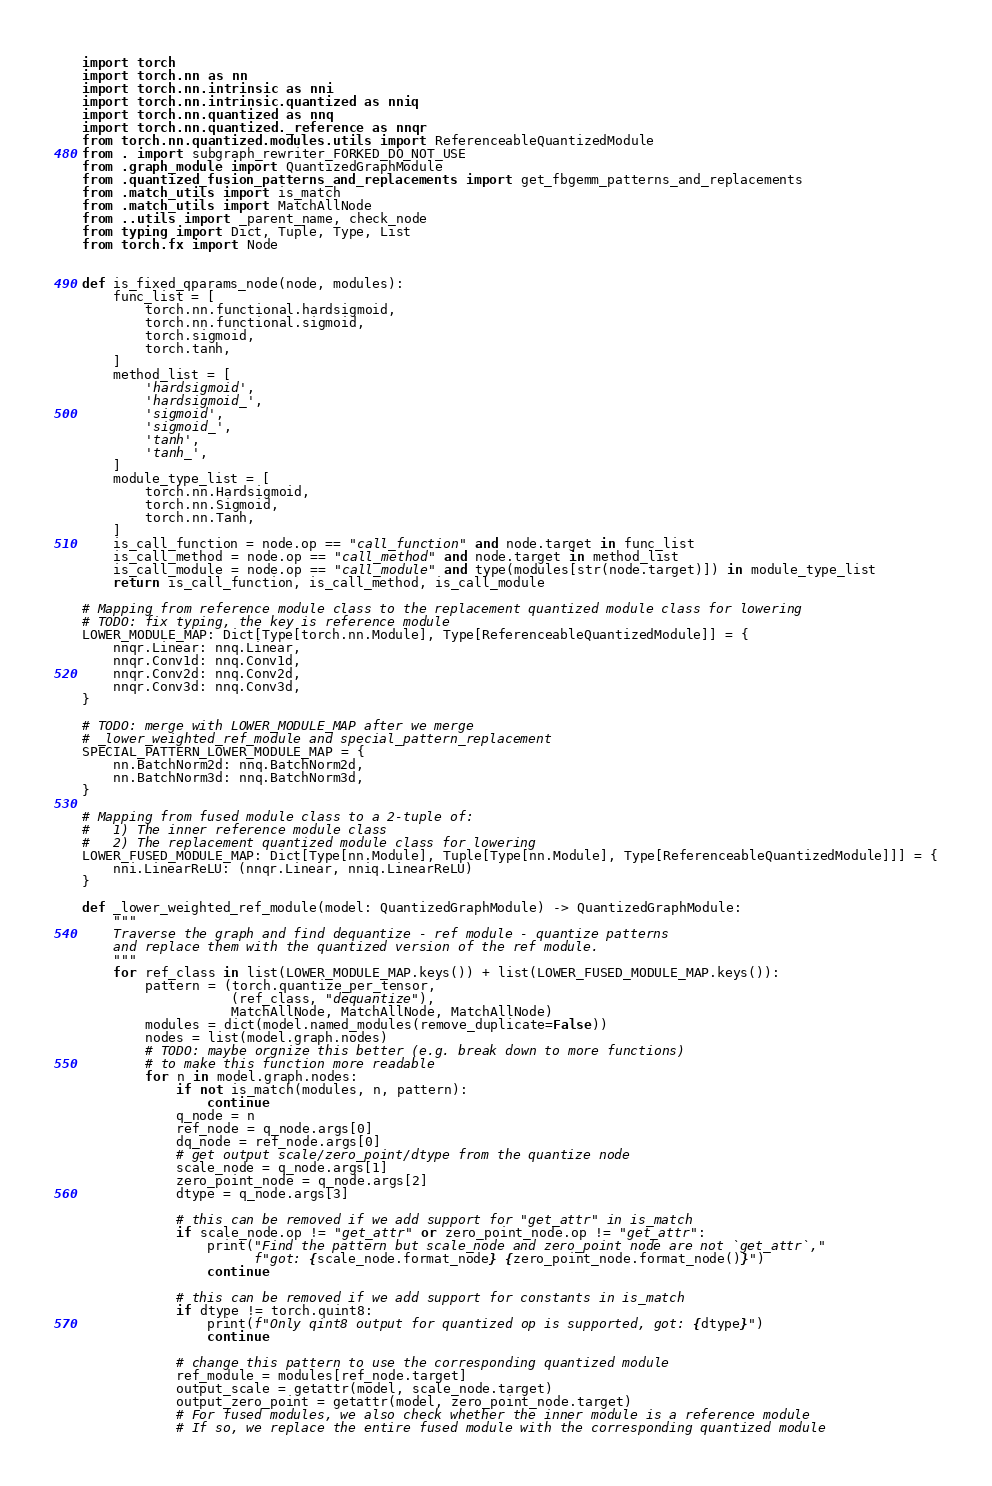Convert code to text. <code><loc_0><loc_0><loc_500><loc_500><_Python_>import torch
import torch.nn as nn
import torch.nn.intrinsic as nni
import torch.nn.intrinsic.quantized as nniq
import torch.nn.quantized as nnq
import torch.nn.quantized._reference as nnqr
from torch.nn.quantized.modules.utils import ReferenceableQuantizedModule
from . import subgraph_rewriter_FORKED_DO_NOT_USE
from .graph_module import QuantizedGraphModule
from .quantized_fusion_patterns_and_replacements import get_fbgemm_patterns_and_replacements
from .match_utils import is_match
from .match_utils import MatchAllNode
from ..utils import _parent_name, check_node
from typing import Dict, Tuple, Type, List
from torch.fx import Node


def is_fixed_qparams_node(node, modules):
    func_list = [
        torch.nn.functional.hardsigmoid,
        torch.nn.functional.sigmoid,
        torch.sigmoid,
        torch.tanh,
    ]
    method_list = [
        'hardsigmoid',
        'hardsigmoid_',
        'sigmoid',
        'sigmoid_',
        'tanh',
        'tanh_',
    ]
    module_type_list = [
        torch.nn.Hardsigmoid,
        torch.nn.Sigmoid,
        torch.nn.Tanh,
    ]
    is_call_function = node.op == "call_function" and node.target in func_list
    is_call_method = node.op == "call_method" and node.target in method_list
    is_call_module = node.op == "call_module" and type(modules[str(node.target)]) in module_type_list
    return is_call_function, is_call_method, is_call_module

# Mapping from reference module class to the replacement quantized module class for lowering
# TODO: fix typing, the key is reference module
LOWER_MODULE_MAP: Dict[Type[torch.nn.Module], Type[ReferenceableQuantizedModule]] = {
    nnqr.Linear: nnq.Linear,
    nnqr.Conv1d: nnq.Conv1d,
    nnqr.Conv2d: nnq.Conv2d,
    nnqr.Conv3d: nnq.Conv3d,
}

# TODO: merge with LOWER_MODULE_MAP after we merge
# _lower_weighted_ref_module and special_pattern_replacement
SPECIAL_PATTERN_LOWER_MODULE_MAP = {
    nn.BatchNorm2d: nnq.BatchNorm2d,
    nn.BatchNorm3d: nnq.BatchNorm3d,
}

# Mapping from fused module class to a 2-tuple of:
#   1) The inner reference module class
#   2) The replacement quantized module class for lowering
LOWER_FUSED_MODULE_MAP: Dict[Type[nn.Module], Tuple[Type[nn.Module], Type[ReferenceableQuantizedModule]]] = {
    nni.LinearReLU: (nnqr.Linear, nniq.LinearReLU)
}

def _lower_weighted_ref_module(model: QuantizedGraphModule) -> QuantizedGraphModule:
    """
    Traverse the graph and find dequantize - ref module - quantize patterns
    and replace them with the quantized version of the ref module.
    """
    for ref_class in list(LOWER_MODULE_MAP.keys()) + list(LOWER_FUSED_MODULE_MAP.keys()):
        pattern = (torch.quantize_per_tensor,
                   (ref_class, "dequantize"),
                   MatchAllNode, MatchAllNode, MatchAllNode)
        modules = dict(model.named_modules(remove_duplicate=False))
        nodes = list(model.graph.nodes)
        # TODO: maybe orgnize this better (e.g. break down to more functions)
        # to make this function more readable
        for n in model.graph.nodes:
            if not is_match(modules, n, pattern):
                continue
            q_node = n
            ref_node = q_node.args[0]
            dq_node = ref_node.args[0]
            # get output scale/zero_point/dtype from the quantize node
            scale_node = q_node.args[1]
            zero_point_node = q_node.args[2]
            dtype = q_node.args[3]

            # this can be removed if we add support for "get_attr" in is_match
            if scale_node.op != "get_attr" or zero_point_node.op != "get_attr":
                print("Find the pattern but scale_node and zero_point node are not `get_attr`,"
                      f"got: {scale_node.format_node} {zero_point_node.format_node()}")
                continue

            # this can be removed if we add support for constants in is_match
            if dtype != torch.quint8:
                print(f"Only qint8 output for quantized op is supported, got: {dtype}")
                continue

            # change this pattern to use the corresponding quantized module
            ref_module = modules[ref_node.target]
            output_scale = getattr(model, scale_node.target)
            output_zero_point = getattr(model, zero_point_node.target)
            # For fused modules, we also check whether the inner module is a reference module
            # If so, we replace the entire fused module with the corresponding quantized module</code> 